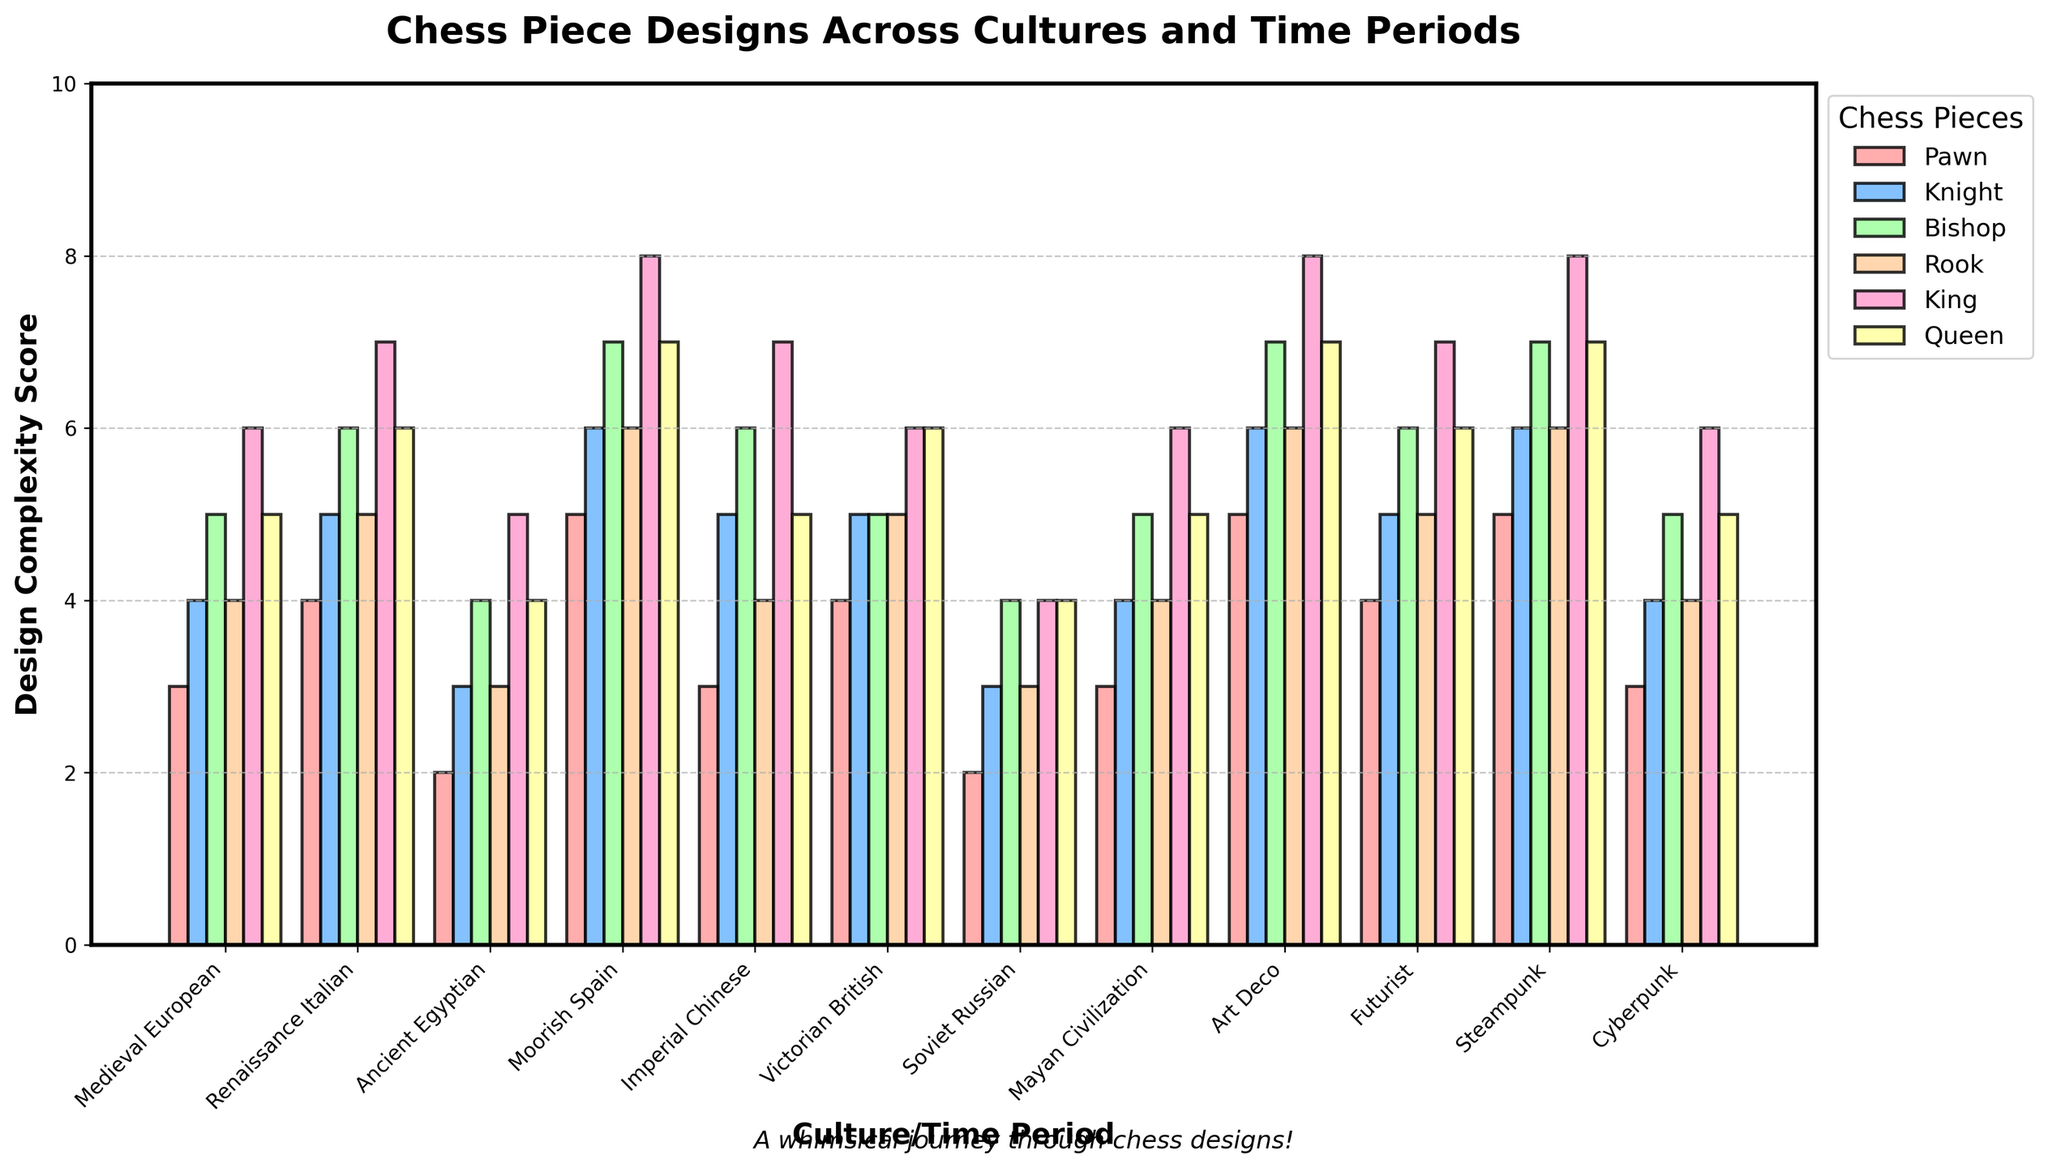Which culture/time period has the most complex Queen design? The highest bar for the Queen design is observed. According to the chart, the Queens from Moorish Spain, Art Deco, and Steampunk all have the highest design complexity score of 7.
Answer: Moorish Spain, Art Deco, Steampunk Which chess piece design is least complex in the Soviet Russian period compared to other periods? The smallest bar for any chess piece in the Soviet Russian period has a value of 3 for both the Pawn and the Rook pieces. Therefore, both the Pawn and Rook designs in the Soviet Russian period are less complex compared to other periods.
Answer: Pawn, Rook What is the average design complexity score for the Rook piece across all periods? To find the average, we sum the Rook scores across all periods and divide by the number of periods. (4 + 5 + 3 + 6 + 4 + 5 + 3 + 4 + 6 + 5 + 6 + 4) / 12 = 55 / 12 ≈ 4.58
Answer: 4.58 How many cultures have a design complexity score of 7 for the King piece? Count the number of bars reaching a height of 7 for the King piece. The periods having a value of 7 for the King are Renaissance Italian, Moorish Spain, Imperial Chinese, Art Deco, Futurist, and Steampunk, totaling 6.
Answer: 6 Which time period has the lowest overall complexity score for all chess pieces combined? Sum the scores for each period and compare them. The period with the lowest overall complexity score is Soviet Russian with a combined score of 20.
Answer: Soviet Russian Compare the design complexity of the Bishop and Knight across all periods. In which periods is the Bishop's design more complex than the Knight's? Compare the bars for Bishop and Knight in each period. The Bishop's design is more complex than the Knight’s in Medieval European, Renaissance Italian, Ancient Egyptian, and Moorish Spain.
Answer: Medieval European, Renaissance Italian, Ancient Egyptian, Moorish Spain How many periods have a Pawn design complexity score of 5? Count the bars representing the Pawn with a height of 5. The periods which have a Pawn design score of 5 are Moorish Spain, Art Deco, and Steampunk, totaling 3.
Answer: 3 Which chess piece consistently has the highest average design complexity score? Calculate the mean score across all periods for each piece by summing their values and dividing by the number of periods. The Queen has the highest average with (5+6+4+7+5+6+4+5+7+6+7+5)/12 = 63 / 12 = 5.25.
Answer: Queen Which culture/time period has the least complexity variation across all chess pieces? Calculate the range (maximum score - minimum score) for each period and find the smallest range. Soviet Russian has the least complexity variation with scores ranging from 2 to 4, a range of 2.
Answer: Soviet Russian 